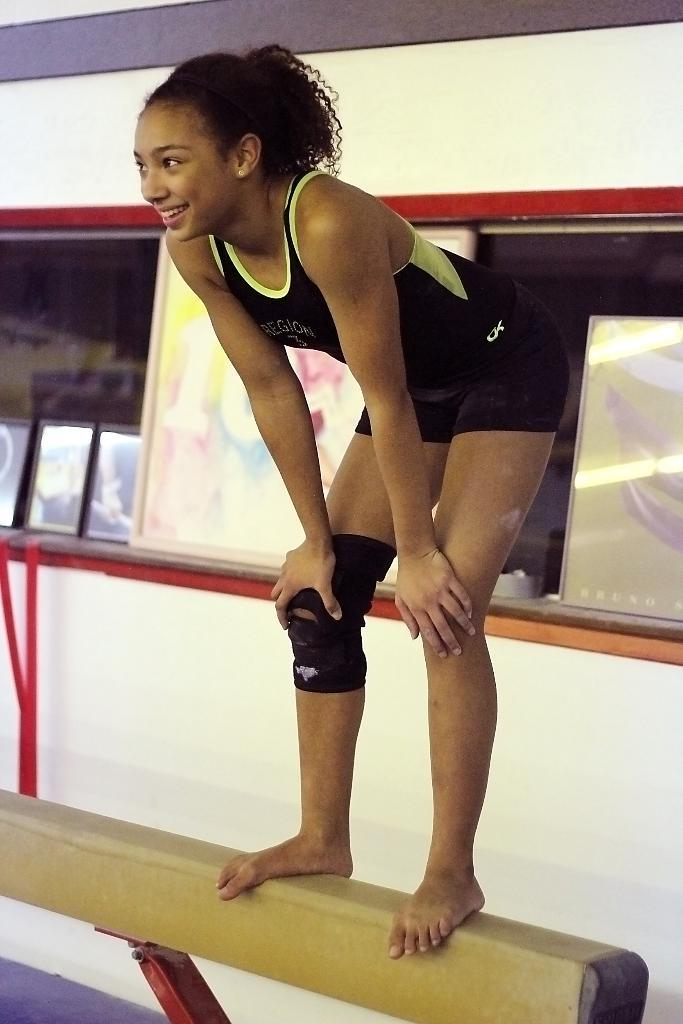What is the woman doing in the image? The woman is standing on a pole in the image. What can be seen in the background of the image? There is a mirror and a photo frame in the background. What type of cord is being used to support the woman on the pole in the image? There is no cord visible in the image; the woman is standing on the pole without any visible support. 